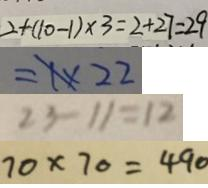<formula> <loc_0><loc_0><loc_500><loc_500>2 + ( 1 0 - 1 ) \times 3 = 2 + 2 7 = 2 9 
 = 1 \times 2 2 
 2 3 - 1 1 = 1 2 
 7 0 \times 7 0 = 4 9 0</formula> 